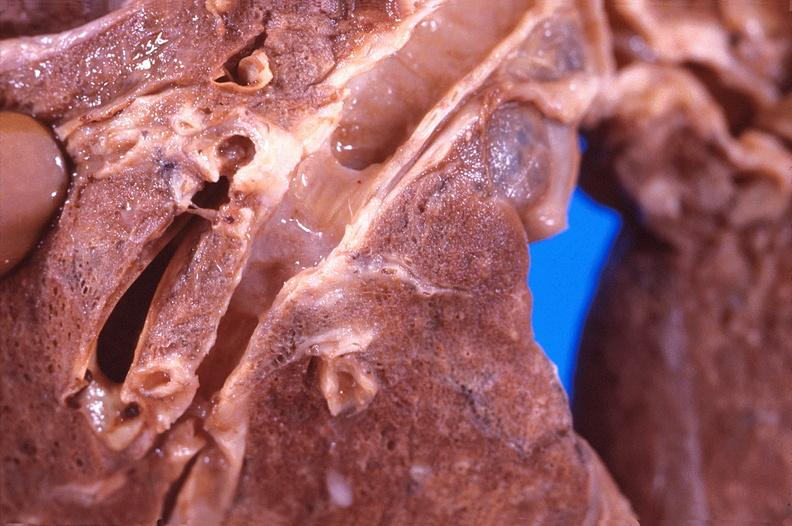does coronary atherosclerosis show lung, bronchiiogenic carcinoma?
Answer the question using a single word or phrase. No 